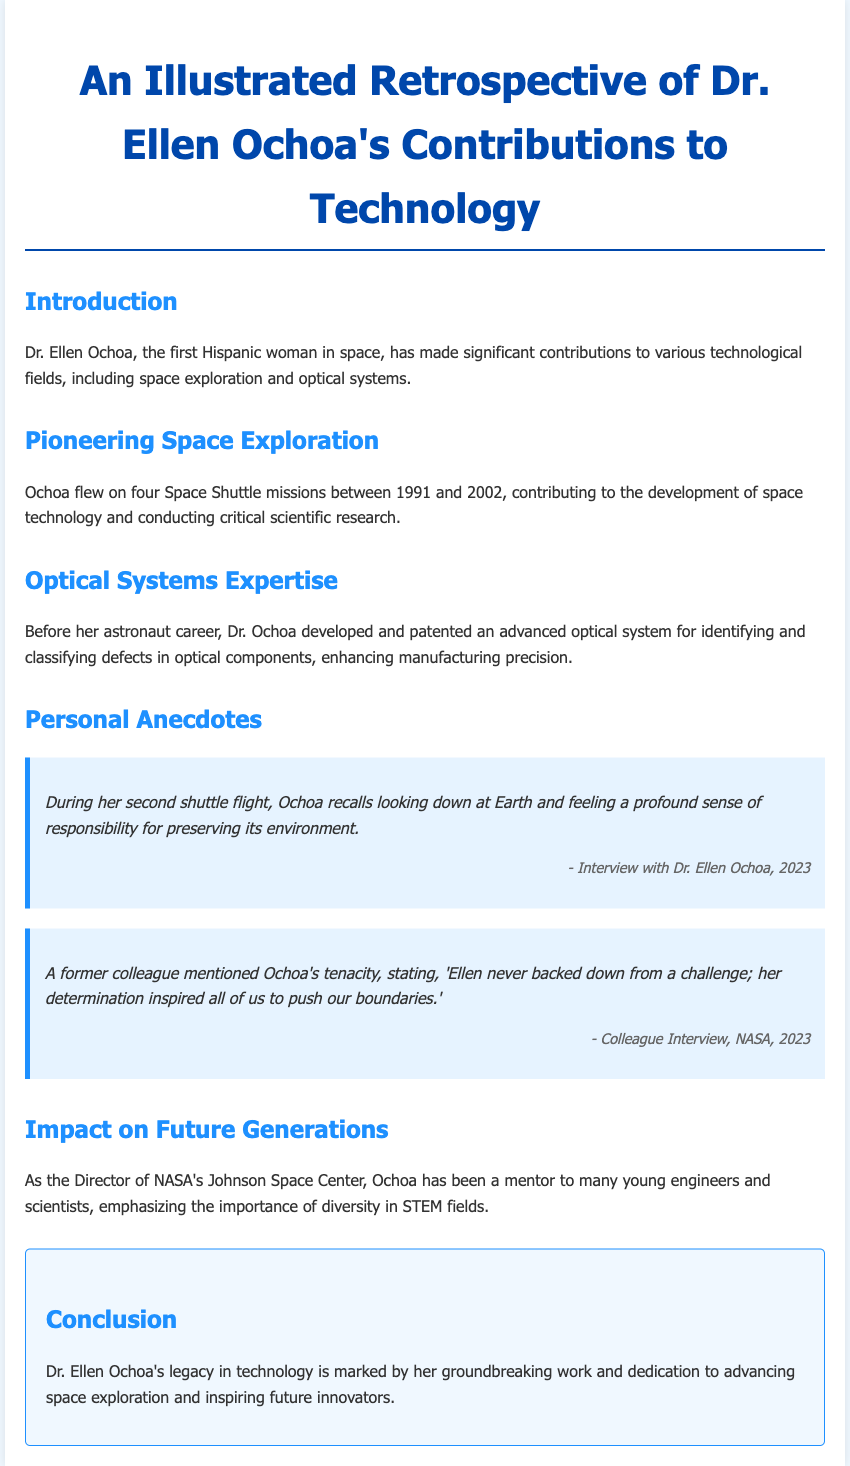What is Dr. Ellen Ochoa's notable achievement in space exploration? Dr. Ellen Ochoa is recognized as the first Hispanic woman in space, a key highlight in her career in space exploration.
Answer: first Hispanic woman in space How many Space Shuttle missions did Ochoa fly on? The document states that Ochoa flew on four Space Shuttle missions between 1991 and 2002.
Answer: four What did Ochoa develop before her astronaut career? Before becoming an astronaut, Ochoa developed and patented an advanced optical system for identifying and classifying defects in optical components.
Answer: advanced optical system What sense did Ochoa experience during her second shuttle flight? Ochoa recalls feeling a profound sense of responsibility for preserving Earth's environment when looking down at Earth during her second shuttle flight.
Answer: responsibility Who is Dr. Ellen Ochoa a mentor to? As the Director of NASA's Johnson Space Center, Ochoa has been a mentor to many young engineers and scientists.
Answer: young engineers and scientists What did a former colleague say about Ochoa's determination? A former colleague mentioned that Ochoa never backed down from a challenge and inspired others with her determination.
Answer: inspired all of us What is the importance of diversity emphasized by Ochoa? Ochoa emphasizes the importance of diversity in STEM fields as part of her mentorship role at NASA.
Answer: importance of diversity in STEM What is the conclusion about Dr. Ochoa's legacy in technology? The conclusion highlights that Dr. Ochoa's legacy is marked by her groundbreaking work and dedication to advancing space exploration.
Answer: groundbreaking work and dedication 